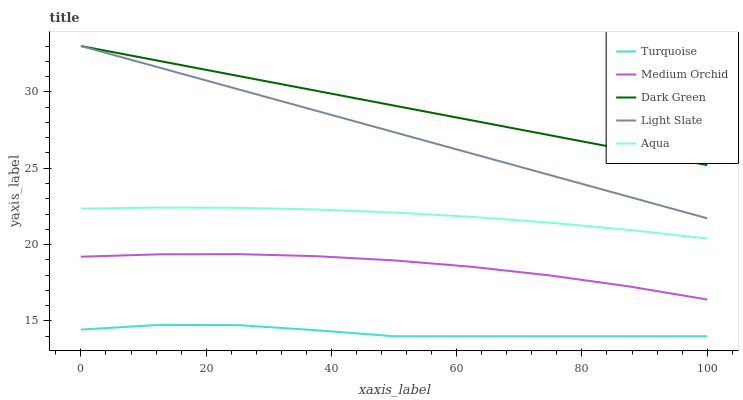Does Turquoise have the minimum area under the curve?
Answer yes or no. Yes. Does Medium Orchid have the minimum area under the curve?
Answer yes or no. No. Does Medium Orchid have the maximum area under the curve?
Answer yes or no. No. Is Turquoise the roughest?
Answer yes or no. Yes. Is Medium Orchid the smoothest?
Answer yes or no. No. Is Medium Orchid the roughest?
Answer yes or no. No. Does Medium Orchid have the lowest value?
Answer yes or no. No. Does Medium Orchid have the highest value?
Answer yes or no. No. Is Aqua less than Light Slate?
Answer yes or no. Yes. Is Medium Orchid greater than Turquoise?
Answer yes or no. Yes. Does Aqua intersect Light Slate?
Answer yes or no. No. 